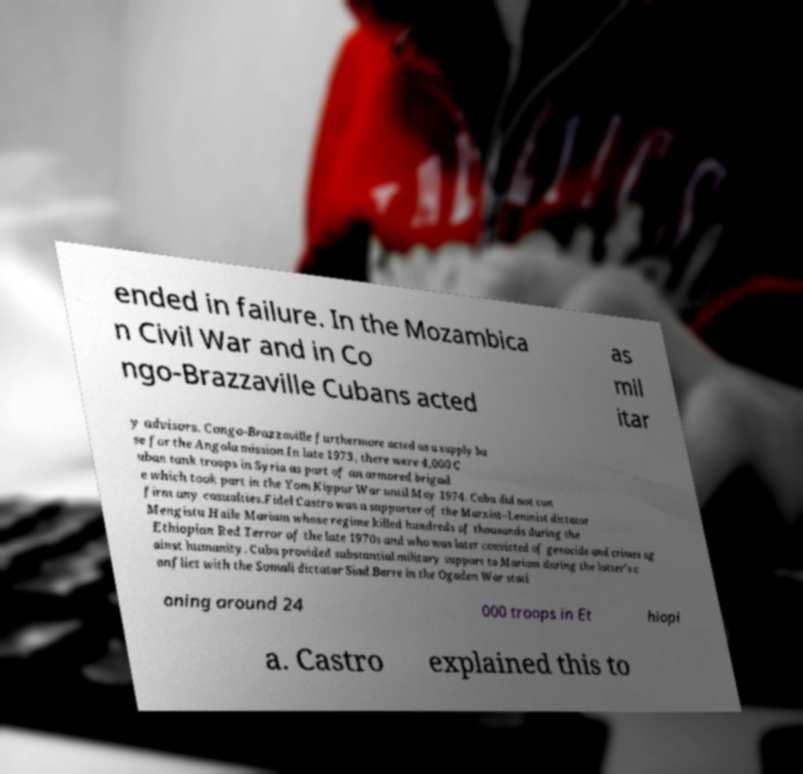Can you accurately transcribe the text from the provided image for me? ended in failure. In the Mozambica n Civil War and in Co ngo-Brazzaville Cubans acted as mil itar y advisors. Congo-Brazzaville furthermore acted as a supply ba se for the Angola mission.In late 1973, there were 4,000 C uban tank troops in Syria as part of an armored brigad e which took part in the Yom Kippur War until May 1974. Cuba did not con firm any casualties.Fidel Castro was a supporter of the Marxist–Leninist dictator Mengistu Haile Mariam whose regime killed hundreds of thousands during the Ethiopian Red Terror of the late 1970s and who was later convicted of genocide and crimes ag ainst humanity. Cuba provided substantial military support to Mariam during the latter's c onflict with the Somali dictator Siad Barre in the Ogaden War stati oning around 24 000 troops in Et hiopi a. Castro explained this to 